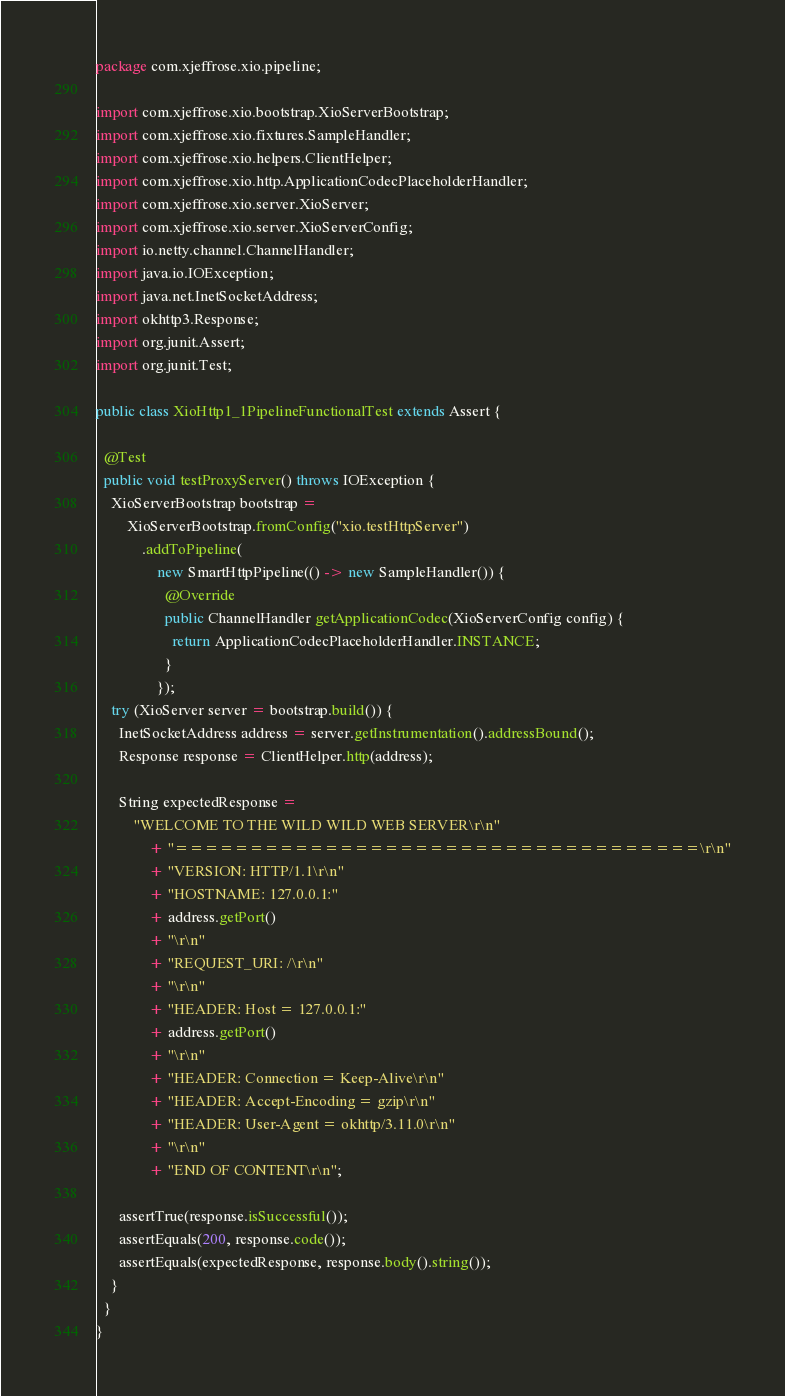<code> <loc_0><loc_0><loc_500><loc_500><_Java_>package com.xjeffrose.xio.pipeline;

import com.xjeffrose.xio.bootstrap.XioServerBootstrap;
import com.xjeffrose.xio.fixtures.SampleHandler;
import com.xjeffrose.xio.helpers.ClientHelper;
import com.xjeffrose.xio.http.ApplicationCodecPlaceholderHandler;
import com.xjeffrose.xio.server.XioServer;
import com.xjeffrose.xio.server.XioServerConfig;
import io.netty.channel.ChannelHandler;
import java.io.IOException;
import java.net.InetSocketAddress;
import okhttp3.Response;
import org.junit.Assert;
import org.junit.Test;

public class XioHttp1_1PipelineFunctionalTest extends Assert {

  @Test
  public void testProxyServer() throws IOException {
    XioServerBootstrap bootstrap =
        XioServerBootstrap.fromConfig("xio.testHttpServer")
            .addToPipeline(
                new SmartHttpPipeline(() -> new SampleHandler()) {
                  @Override
                  public ChannelHandler getApplicationCodec(XioServerConfig config) {
                    return ApplicationCodecPlaceholderHandler.INSTANCE;
                  }
                });
    try (XioServer server = bootstrap.build()) {
      InetSocketAddress address = server.getInstrumentation().addressBound();
      Response response = ClientHelper.http(address);

      String expectedResponse =
          "WELCOME TO THE WILD WILD WEB SERVER\r\n"
              + "===================================\r\n"
              + "VERSION: HTTP/1.1\r\n"
              + "HOSTNAME: 127.0.0.1:"
              + address.getPort()
              + "\r\n"
              + "REQUEST_URI: /\r\n"
              + "\r\n"
              + "HEADER: Host = 127.0.0.1:"
              + address.getPort()
              + "\r\n"
              + "HEADER: Connection = Keep-Alive\r\n"
              + "HEADER: Accept-Encoding = gzip\r\n"
              + "HEADER: User-Agent = okhttp/3.11.0\r\n"
              + "\r\n"
              + "END OF CONTENT\r\n";

      assertTrue(response.isSuccessful());
      assertEquals(200, response.code());
      assertEquals(expectedResponse, response.body().string());
    }
  }
}
</code> 